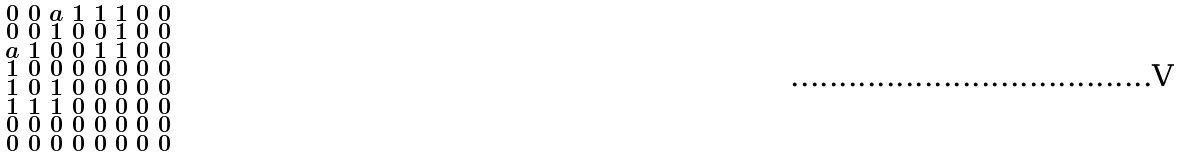<formula> <loc_0><loc_0><loc_500><loc_500>\begin{smallmatrix} 0 & 0 & a & 1 & 1 & 1 & 0 & 0 \\ 0 & 0 & 1 & 0 & 0 & 1 & 0 & 0 \\ a & 1 & 0 & 0 & 1 & 1 & 0 & 0 \\ 1 & 0 & 0 & 0 & 0 & 0 & 0 & 0 \\ 1 & 0 & 1 & 0 & 0 & 0 & 0 & 0 \\ 1 & 1 & 1 & 0 & 0 & 0 & 0 & 0 \\ 0 & 0 & 0 & 0 & 0 & 0 & 0 & 0 \\ 0 & 0 & 0 & 0 & 0 & 0 & 0 & 0 \end{smallmatrix}</formula> 